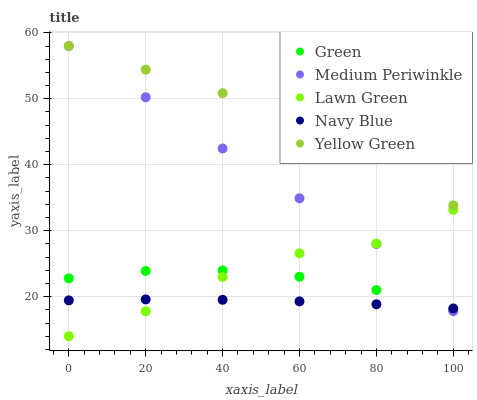Does Navy Blue have the minimum area under the curve?
Answer yes or no. Yes. Does Yellow Green have the maximum area under the curve?
Answer yes or no. Yes. Does Green have the minimum area under the curve?
Answer yes or no. No. Does Green have the maximum area under the curve?
Answer yes or no. No. Is Navy Blue the smoothest?
Answer yes or no. Yes. Is Yellow Green the roughest?
Answer yes or no. Yes. Is Green the smoothest?
Answer yes or no. No. Is Green the roughest?
Answer yes or no. No. Does Lawn Green have the lowest value?
Answer yes or no. Yes. Does Navy Blue have the lowest value?
Answer yes or no. No. Does Yellow Green have the highest value?
Answer yes or no. Yes. Does Green have the highest value?
Answer yes or no. No. Is Green less than Yellow Green?
Answer yes or no. Yes. Is Yellow Green greater than Green?
Answer yes or no. Yes. Does Medium Periwinkle intersect Navy Blue?
Answer yes or no. Yes. Is Medium Periwinkle less than Navy Blue?
Answer yes or no. No. Is Medium Periwinkle greater than Navy Blue?
Answer yes or no. No. Does Green intersect Yellow Green?
Answer yes or no. No. 